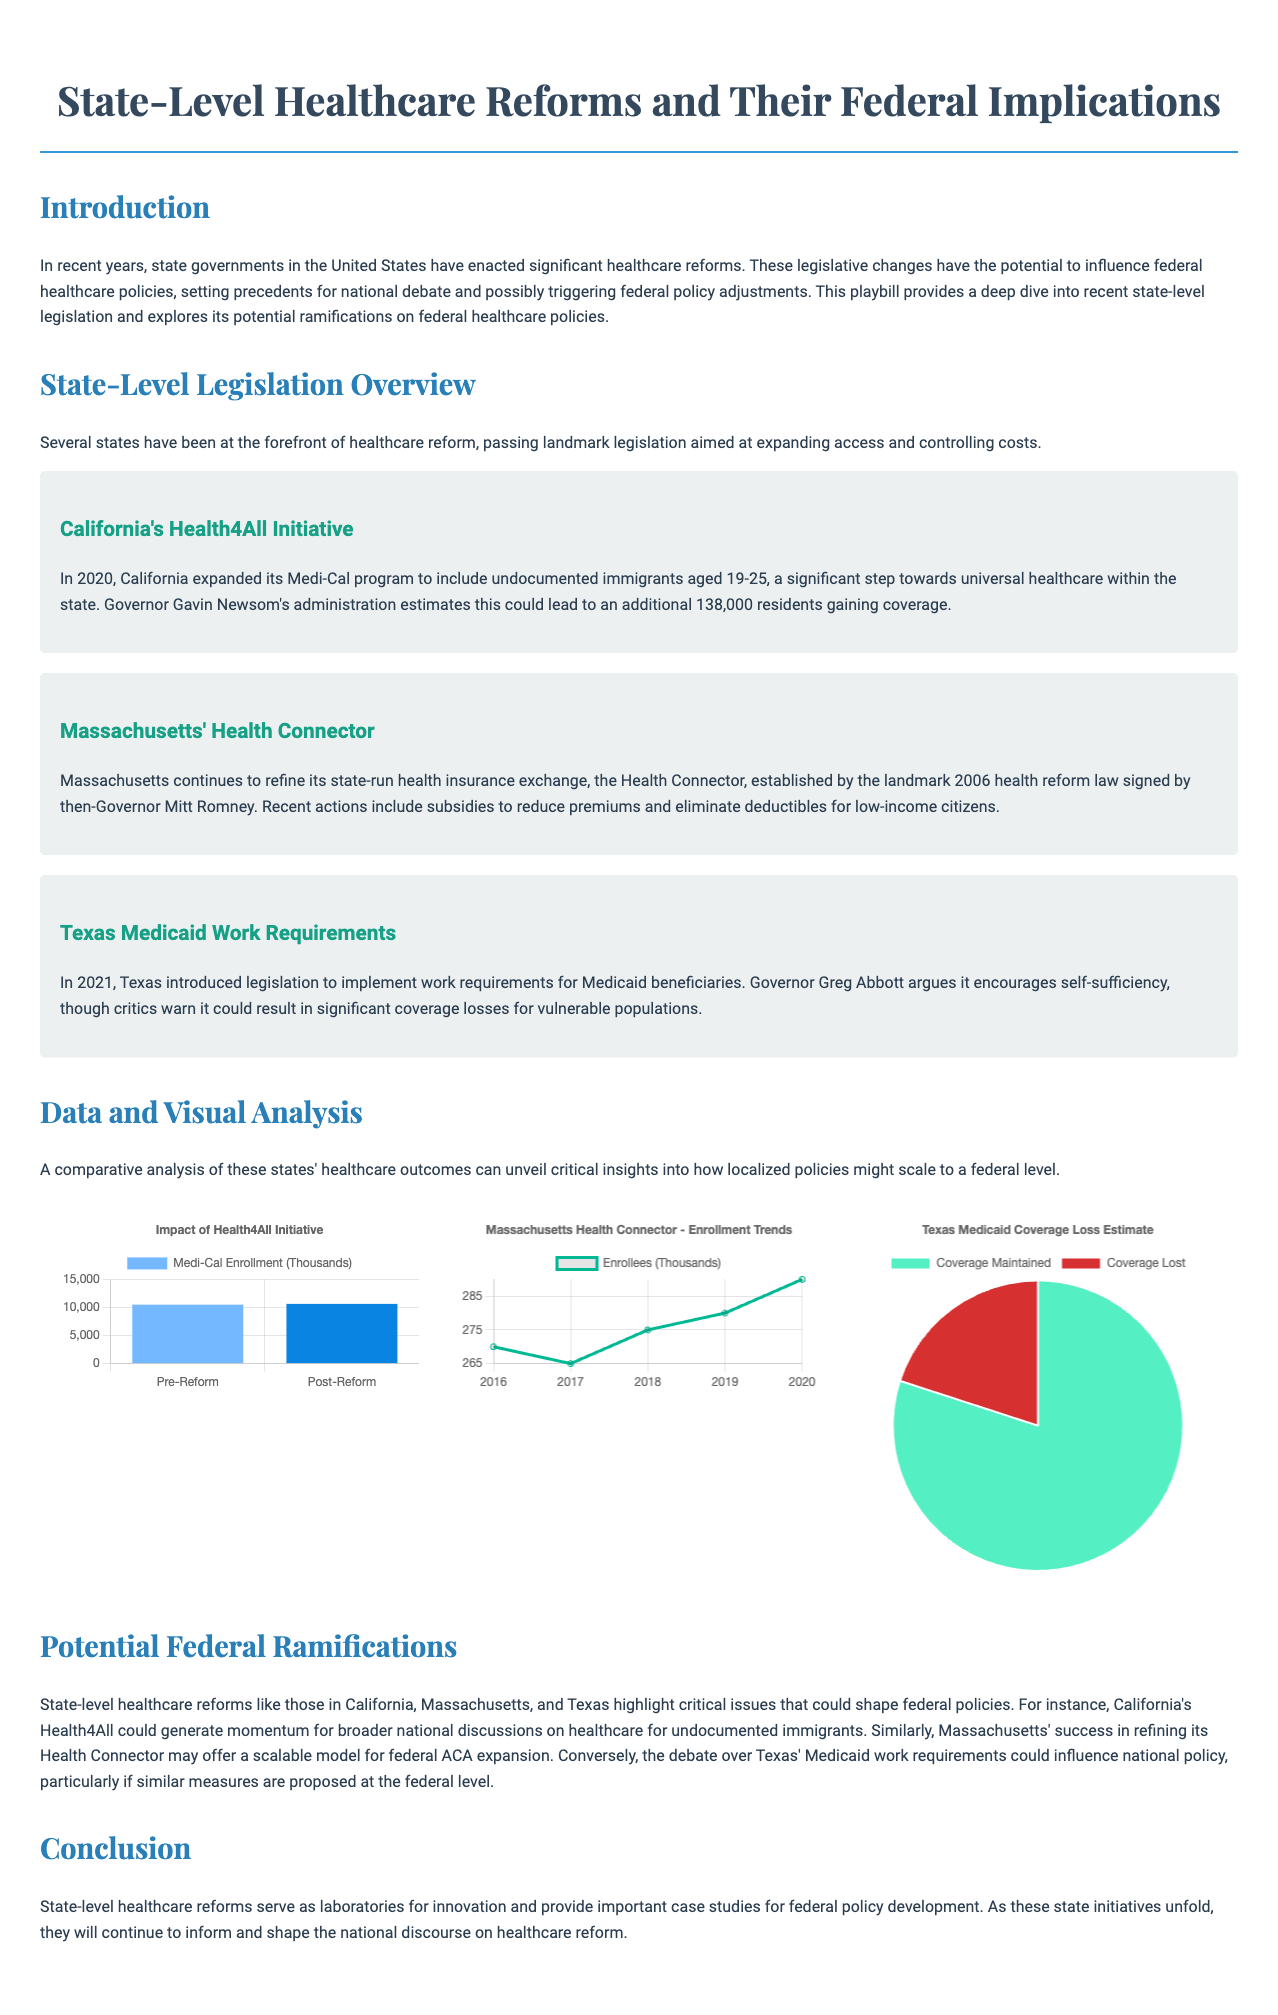What is California's healthcare initiative called? California's healthcare initiative aimed at expanding access is referred to as the Health4All Initiative.
Answer: Health4All Initiative How many residents does California estimate will gain coverage from the Health4All Initiative? The document states that California estimates an additional 138,000 residents will gain coverage from the initiative.
Answer: 138,000 What is the focus of Texas' 2021 healthcare legislation? The 2021 healthcare legislation in Texas introduced work requirements for Medicaid beneficiaries.
Answer: Work requirements Which year was Massachusetts' Health Connector established? The Health Connector in Massachusetts was established by a landmark health reform law signed in 2006.
Answer: 2006 What percentage of Medicaid coverage is estimated to be maintained in Texas? The pie chart indicates that it's estimated that 80 percent of Medicaid coverage will be maintained.
Answer: 80 What trend does the Massachusetts Health Connector data portray from 2016 to 2020? The enrollment trend in Massachusetts shows an increasing number of enrollees from 270,000 in 2016 to 290,000 in 2020.
Answer: Increasing What potential impact does California's Health4All have on federal discussions? California's Health4All initiative is expected to generate momentum for national discussions on healthcare for undocumented immigrants.
Answer: National discussions What is a key argument in favor of Texas' Medicaid work requirements? Proponents argue that work requirements encourage self-sufficiency among Medicaid beneficiaries.
Answer: Self-sufficiency What type of analysis is provided for state-level healthcare reforms? The document provides a comparative analysis of healthcare outcomes related to state-level healthcare reforms.
Answer: Comparative analysis 